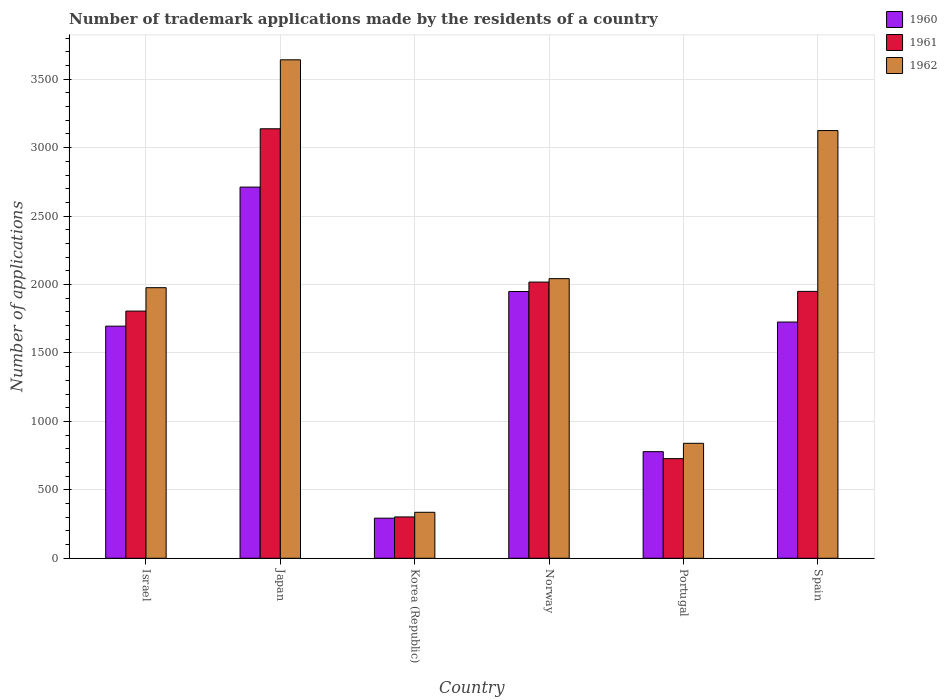How many different coloured bars are there?
Keep it short and to the point. 3. How many groups of bars are there?
Make the answer very short. 6. Are the number of bars on each tick of the X-axis equal?
Offer a terse response. Yes. How many bars are there on the 1st tick from the right?
Provide a short and direct response. 3. What is the number of trademark applications made by the residents in 1961 in Norway?
Your answer should be very brief. 2018. Across all countries, what is the maximum number of trademark applications made by the residents in 1962?
Your answer should be compact. 3642. Across all countries, what is the minimum number of trademark applications made by the residents in 1961?
Provide a succinct answer. 302. In which country was the number of trademark applications made by the residents in 1962 maximum?
Give a very brief answer. Japan. What is the total number of trademark applications made by the residents in 1962 in the graph?
Offer a terse response. 1.20e+04. What is the difference between the number of trademark applications made by the residents in 1961 in Japan and that in Portugal?
Offer a very short reply. 2410. What is the difference between the number of trademark applications made by the residents in 1961 in Portugal and the number of trademark applications made by the residents in 1960 in Spain?
Ensure brevity in your answer.  -998. What is the average number of trademark applications made by the residents in 1960 per country?
Offer a terse response. 1525.83. In how many countries, is the number of trademark applications made by the residents in 1961 greater than 2800?
Keep it short and to the point. 1. What is the ratio of the number of trademark applications made by the residents in 1960 in Norway to that in Portugal?
Give a very brief answer. 2.5. Is the number of trademark applications made by the residents in 1960 in Israel less than that in Norway?
Offer a very short reply. Yes. What is the difference between the highest and the second highest number of trademark applications made by the residents in 1961?
Keep it short and to the point. 1120. What is the difference between the highest and the lowest number of trademark applications made by the residents in 1962?
Offer a very short reply. 3306. In how many countries, is the number of trademark applications made by the residents in 1962 greater than the average number of trademark applications made by the residents in 1962 taken over all countries?
Keep it short and to the point. 3. Is the sum of the number of trademark applications made by the residents in 1960 in Israel and Korea (Republic) greater than the maximum number of trademark applications made by the residents in 1962 across all countries?
Ensure brevity in your answer.  No. What does the 2nd bar from the left in Norway represents?
Make the answer very short. 1961. How many bars are there?
Offer a terse response. 18. Are all the bars in the graph horizontal?
Give a very brief answer. No. How many countries are there in the graph?
Keep it short and to the point. 6. What is the difference between two consecutive major ticks on the Y-axis?
Offer a very short reply. 500. Does the graph contain any zero values?
Ensure brevity in your answer.  No. Does the graph contain grids?
Your answer should be compact. Yes. What is the title of the graph?
Provide a short and direct response. Number of trademark applications made by the residents of a country. Does "1960" appear as one of the legend labels in the graph?
Offer a very short reply. Yes. What is the label or title of the X-axis?
Ensure brevity in your answer.  Country. What is the label or title of the Y-axis?
Your response must be concise. Number of applications. What is the Number of applications of 1960 in Israel?
Give a very brief answer. 1696. What is the Number of applications in 1961 in Israel?
Make the answer very short. 1806. What is the Number of applications in 1962 in Israel?
Your answer should be very brief. 1977. What is the Number of applications of 1960 in Japan?
Provide a succinct answer. 2712. What is the Number of applications of 1961 in Japan?
Offer a very short reply. 3138. What is the Number of applications in 1962 in Japan?
Ensure brevity in your answer.  3642. What is the Number of applications in 1960 in Korea (Republic)?
Make the answer very short. 293. What is the Number of applications in 1961 in Korea (Republic)?
Give a very brief answer. 302. What is the Number of applications of 1962 in Korea (Republic)?
Provide a short and direct response. 336. What is the Number of applications in 1960 in Norway?
Your answer should be compact. 1949. What is the Number of applications of 1961 in Norway?
Your response must be concise. 2018. What is the Number of applications in 1962 in Norway?
Provide a short and direct response. 2043. What is the Number of applications in 1960 in Portugal?
Make the answer very short. 779. What is the Number of applications of 1961 in Portugal?
Give a very brief answer. 728. What is the Number of applications in 1962 in Portugal?
Give a very brief answer. 840. What is the Number of applications in 1960 in Spain?
Your response must be concise. 1726. What is the Number of applications of 1961 in Spain?
Keep it short and to the point. 1950. What is the Number of applications of 1962 in Spain?
Provide a succinct answer. 3125. Across all countries, what is the maximum Number of applications in 1960?
Your response must be concise. 2712. Across all countries, what is the maximum Number of applications in 1961?
Keep it short and to the point. 3138. Across all countries, what is the maximum Number of applications of 1962?
Your answer should be very brief. 3642. Across all countries, what is the minimum Number of applications in 1960?
Your answer should be very brief. 293. Across all countries, what is the minimum Number of applications of 1961?
Provide a short and direct response. 302. Across all countries, what is the minimum Number of applications of 1962?
Ensure brevity in your answer.  336. What is the total Number of applications in 1960 in the graph?
Provide a succinct answer. 9155. What is the total Number of applications in 1961 in the graph?
Provide a short and direct response. 9942. What is the total Number of applications in 1962 in the graph?
Offer a terse response. 1.20e+04. What is the difference between the Number of applications in 1960 in Israel and that in Japan?
Your answer should be compact. -1016. What is the difference between the Number of applications in 1961 in Israel and that in Japan?
Give a very brief answer. -1332. What is the difference between the Number of applications of 1962 in Israel and that in Japan?
Your answer should be very brief. -1665. What is the difference between the Number of applications of 1960 in Israel and that in Korea (Republic)?
Offer a terse response. 1403. What is the difference between the Number of applications of 1961 in Israel and that in Korea (Republic)?
Make the answer very short. 1504. What is the difference between the Number of applications in 1962 in Israel and that in Korea (Republic)?
Offer a very short reply. 1641. What is the difference between the Number of applications of 1960 in Israel and that in Norway?
Provide a short and direct response. -253. What is the difference between the Number of applications of 1961 in Israel and that in Norway?
Provide a succinct answer. -212. What is the difference between the Number of applications of 1962 in Israel and that in Norway?
Keep it short and to the point. -66. What is the difference between the Number of applications of 1960 in Israel and that in Portugal?
Give a very brief answer. 917. What is the difference between the Number of applications in 1961 in Israel and that in Portugal?
Offer a very short reply. 1078. What is the difference between the Number of applications of 1962 in Israel and that in Portugal?
Provide a short and direct response. 1137. What is the difference between the Number of applications in 1961 in Israel and that in Spain?
Make the answer very short. -144. What is the difference between the Number of applications of 1962 in Israel and that in Spain?
Give a very brief answer. -1148. What is the difference between the Number of applications of 1960 in Japan and that in Korea (Republic)?
Your response must be concise. 2419. What is the difference between the Number of applications in 1961 in Japan and that in Korea (Republic)?
Provide a short and direct response. 2836. What is the difference between the Number of applications in 1962 in Japan and that in Korea (Republic)?
Ensure brevity in your answer.  3306. What is the difference between the Number of applications of 1960 in Japan and that in Norway?
Keep it short and to the point. 763. What is the difference between the Number of applications in 1961 in Japan and that in Norway?
Keep it short and to the point. 1120. What is the difference between the Number of applications in 1962 in Japan and that in Norway?
Provide a short and direct response. 1599. What is the difference between the Number of applications in 1960 in Japan and that in Portugal?
Your response must be concise. 1933. What is the difference between the Number of applications of 1961 in Japan and that in Portugal?
Keep it short and to the point. 2410. What is the difference between the Number of applications of 1962 in Japan and that in Portugal?
Your response must be concise. 2802. What is the difference between the Number of applications in 1960 in Japan and that in Spain?
Offer a terse response. 986. What is the difference between the Number of applications in 1961 in Japan and that in Spain?
Your answer should be compact. 1188. What is the difference between the Number of applications in 1962 in Japan and that in Spain?
Offer a very short reply. 517. What is the difference between the Number of applications in 1960 in Korea (Republic) and that in Norway?
Your response must be concise. -1656. What is the difference between the Number of applications in 1961 in Korea (Republic) and that in Norway?
Offer a terse response. -1716. What is the difference between the Number of applications in 1962 in Korea (Republic) and that in Norway?
Give a very brief answer. -1707. What is the difference between the Number of applications of 1960 in Korea (Republic) and that in Portugal?
Offer a very short reply. -486. What is the difference between the Number of applications in 1961 in Korea (Republic) and that in Portugal?
Offer a very short reply. -426. What is the difference between the Number of applications in 1962 in Korea (Republic) and that in Portugal?
Ensure brevity in your answer.  -504. What is the difference between the Number of applications of 1960 in Korea (Republic) and that in Spain?
Your answer should be compact. -1433. What is the difference between the Number of applications in 1961 in Korea (Republic) and that in Spain?
Your response must be concise. -1648. What is the difference between the Number of applications of 1962 in Korea (Republic) and that in Spain?
Make the answer very short. -2789. What is the difference between the Number of applications in 1960 in Norway and that in Portugal?
Keep it short and to the point. 1170. What is the difference between the Number of applications in 1961 in Norway and that in Portugal?
Keep it short and to the point. 1290. What is the difference between the Number of applications of 1962 in Norway and that in Portugal?
Give a very brief answer. 1203. What is the difference between the Number of applications of 1960 in Norway and that in Spain?
Your response must be concise. 223. What is the difference between the Number of applications in 1962 in Norway and that in Spain?
Provide a short and direct response. -1082. What is the difference between the Number of applications in 1960 in Portugal and that in Spain?
Offer a very short reply. -947. What is the difference between the Number of applications of 1961 in Portugal and that in Spain?
Give a very brief answer. -1222. What is the difference between the Number of applications in 1962 in Portugal and that in Spain?
Your answer should be very brief. -2285. What is the difference between the Number of applications in 1960 in Israel and the Number of applications in 1961 in Japan?
Keep it short and to the point. -1442. What is the difference between the Number of applications of 1960 in Israel and the Number of applications of 1962 in Japan?
Your answer should be compact. -1946. What is the difference between the Number of applications in 1961 in Israel and the Number of applications in 1962 in Japan?
Your response must be concise. -1836. What is the difference between the Number of applications in 1960 in Israel and the Number of applications in 1961 in Korea (Republic)?
Ensure brevity in your answer.  1394. What is the difference between the Number of applications in 1960 in Israel and the Number of applications in 1962 in Korea (Republic)?
Make the answer very short. 1360. What is the difference between the Number of applications in 1961 in Israel and the Number of applications in 1962 in Korea (Republic)?
Keep it short and to the point. 1470. What is the difference between the Number of applications in 1960 in Israel and the Number of applications in 1961 in Norway?
Offer a terse response. -322. What is the difference between the Number of applications in 1960 in Israel and the Number of applications in 1962 in Norway?
Offer a terse response. -347. What is the difference between the Number of applications of 1961 in Israel and the Number of applications of 1962 in Norway?
Your response must be concise. -237. What is the difference between the Number of applications of 1960 in Israel and the Number of applications of 1961 in Portugal?
Offer a very short reply. 968. What is the difference between the Number of applications in 1960 in Israel and the Number of applications in 1962 in Portugal?
Your response must be concise. 856. What is the difference between the Number of applications of 1961 in Israel and the Number of applications of 1962 in Portugal?
Give a very brief answer. 966. What is the difference between the Number of applications of 1960 in Israel and the Number of applications of 1961 in Spain?
Offer a very short reply. -254. What is the difference between the Number of applications of 1960 in Israel and the Number of applications of 1962 in Spain?
Your answer should be compact. -1429. What is the difference between the Number of applications in 1961 in Israel and the Number of applications in 1962 in Spain?
Provide a succinct answer. -1319. What is the difference between the Number of applications in 1960 in Japan and the Number of applications in 1961 in Korea (Republic)?
Provide a succinct answer. 2410. What is the difference between the Number of applications in 1960 in Japan and the Number of applications in 1962 in Korea (Republic)?
Provide a short and direct response. 2376. What is the difference between the Number of applications in 1961 in Japan and the Number of applications in 1962 in Korea (Republic)?
Offer a very short reply. 2802. What is the difference between the Number of applications in 1960 in Japan and the Number of applications in 1961 in Norway?
Make the answer very short. 694. What is the difference between the Number of applications in 1960 in Japan and the Number of applications in 1962 in Norway?
Give a very brief answer. 669. What is the difference between the Number of applications of 1961 in Japan and the Number of applications of 1962 in Norway?
Your response must be concise. 1095. What is the difference between the Number of applications in 1960 in Japan and the Number of applications in 1961 in Portugal?
Provide a short and direct response. 1984. What is the difference between the Number of applications in 1960 in Japan and the Number of applications in 1962 in Portugal?
Offer a terse response. 1872. What is the difference between the Number of applications in 1961 in Japan and the Number of applications in 1962 in Portugal?
Your answer should be compact. 2298. What is the difference between the Number of applications of 1960 in Japan and the Number of applications of 1961 in Spain?
Ensure brevity in your answer.  762. What is the difference between the Number of applications of 1960 in Japan and the Number of applications of 1962 in Spain?
Your answer should be very brief. -413. What is the difference between the Number of applications in 1961 in Japan and the Number of applications in 1962 in Spain?
Provide a succinct answer. 13. What is the difference between the Number of applications in 1960 in Korea (Republic) and the Number of applications in 1961 in Norway?
Offer a terse response. -1725. What is the difference between the Number of applications in 1960 in Korea (Republic) and the Number of applications in 1962 in Norway?
Ensure brevity in your answer.  -1750. What is the difference between the Number of applications in 1961 in Korea (Republic) and the Number of applications in 1962 in Norway?
Your response must be concise. -1741. What is the difference between the Number of applications in 1960 in Korea (Republic) and the Number of applications in 1961 in Portugal?
Your answer should be compact. -435. What is the difference between the Number of applications in 1960 in Korea (Republic) and the Number of applications in 1962 in Portugal?
Keep it short and to the point. -547. What is the difference between the Number of applications in 1961 in Korea (Republic) and the Number of applications in 1962 in Portugal?
Your answer should be very brief. -538. What is the difference between the Number of applications in 1960 in Korea (Republic) and the Number of applications in 1961 in Spain?
Offer a terse response. -1657. What is the difference between the Number of applications in 1960 in Korea (Republic) and the Number of applications in 1962 in Spain?
Offer a terse response. -2832. What is the difference between the Number of applications of 1961 in Korea (Republic) and the Number of applications of 1962 in Spain?
Make the answer very short. -2823. What is the difference between the Number of applications in 1960 in Norway and the Number of applications in 1961 in Portugal?
Ensure brevity in your answer.  1221. What is the difference between the Number of applications of 1960 in Norway and the Number of applications of 1962 in Portugal?
Provide a short and direct response. 1109. What is the difference between the Number of applications in 1961 in Norway and the Number of applications in 1962 in Portugal?
Ensure brevity in your answer.  1178. What is the difference between the Number of applications in 1960 in Norway and the Number of applications in 1962 in Spain?
Your response must be concise. -1176. What is the difference between the Number of applications in 1961 in Norway and the Number of applications in 1962 in Spain?
Keep it short and to the point. -1107. What is the difference between the Number of applications of 1960 in Portugal and the Number of applications of 1961 in Spain?
Give a very brief answer. -1171. What is the difference between the Number of applications in 1960 in Portugal and the Number of applications in 1962 in Spain?
Provide a short and direct response. -2346. What is the difference between the Number of applications in 1961 in Portugal and the Number of applications in 1962 in Spain?
Provide a succinct answer. -2397. What is the average Number of applications in 1960 per country?
Ensure brevity in your answer.  1525.83. What is the average Number of applications in 1961 per country?
Your answer should be very brief. 1657. What is the average Number of applications in 1962 per country?
Offer a terse response. 1993.83. What is the difference between the Number of applications of 1960 and Number of applications of 1961 in Israel?
Offer a terse response. -110. What is the difference between the Number of applications of 1960 and Number of applications of 1962 in Israel?
Ensure brevity in your answer.  -281. What is the difference between the Number of applications in 1961 and Number of applications in 1962 in Israel?
Ensure brevity in your answer.  -171. What is the difference between the Number of applications of 1960 and Number of applications of 1961 in Japan?
Give a very brief answer. -426. What is the difference between the Number of applications in 1960 and Number of applications in 1962 in Japan?
Provide a succinct answer. -930. What is the difference between the Number of applications in 1961 and Number of applications in 1962 in Japan?
Provide a succinct answer. -504. What is the difference between the Number of applications in 1960 and Number of applications in 1961 in Korea (Republic)?
Your answer should be very brief. -9. What is the difference between the Number of applications in 1960 and Number of applications in 1962 in Korea (Republic)?
Offer a very short reply. -43. What is the difference between the Number of applications of 1961 and Number of applications of 1962 in Korea (Republic)?
Provide a short and direct response. -34. What is the difference between the Number of applications of 1960 and Number of applications of 1961 in Norway?
Your response must be concise. -69. What is the difference between the Number of applications in 1960 and Number of applications in 1962 in Norway?
Provide a succinct answer. -94. What is the difference between the Number of applications of 1960 and Number of applications of 1961 in Portugal?
Provide a short and direct response. 51. What is the difference between the Number of applications in 1960 and Number of applications in 1962 in Portugal?
Your answer should be very brief. -61. What is the difference between the Number of applications of 1961 and Number of applications of 1962 in Portugal?
Keep it short and to the point. -112. What is the difference between the Number of applications in 1960 and Number of applications in 1961 in Spain?
Provide a succinct answer. -224. What is the difference between the Number of applications in 1960 and Number of applications in 1962 in Spain?
Offer a terse response. -1399. What is the difference between the Number of applications in 1961 and Number of applications in 1962 in Spain?
Offer a terse response. -1175. What is the ratio of the Number of applications of 1960 in Israel to that in Japan?
Provide a succinct answer. 0.63. What is the ratio of the Number of applications of 1961 in Israel to that in Japan?
Your answer should be compact. 0.58. What is the ratio of the Number of applications of 1962 in Israel to that in Japan?
Make the answer very short. 0.54. What is the ratio of the Number of applications of 1960 in Israel to that in Korea (Republic)?
Provide a short and direct response. 5.79. What is the ratio of the Number of applications in 1961 in Israel to that in Korea (Republic)?
Your answer should be very brief. 5.98. What is the ratio of the Number of applications in 1962 in Israel to that in Korea (Republic)?
Provide a short and direct response. 5.88. What is the ratio of the Number of applications of 1960 in Israel to that in Norway?
Make the answer very short. 0.87. What is the ratio of the Number of applications of 1961 in Israel to that in Norway?
Offer a terse response. 0.89. What is the ratio of the Number of applications of 1962 in Israel to that in Norway?
Make the answer very short. 0.97. What is the ratio of the Number of applications in 1960 in Israel to that in Portugal?
Make the answer very short. 2.18. What is the ratio of the Number of applications in 1961 in Israel to that in Portugal?
Make the answer very short. 2.48. What is the ratio of the Number of applications in 1962 in Israel to that in Portugal?
Offer a terse response. 2.35. What is the ratio of the Number of applications of 1960 in Israel to that in Spain?
Your response must be concise. 0.98. What is the ratio of the Number of applications of 1961 in Israel to that in Spain?
Provide a short and direct response. 0.93. What is the ratio of the Number of applications in 1962 in Israel to that in Spain?
Provide a short and direct response. 0.63. What is the ratio of the Number of applications of 1960 in Japan to that in Korea (Republic)?
Provide a succinct answer. 9.26. What is the ratio of the Number of applications in 1961 in Japan to that in Korea (Republic)?
Give a very brief answer. 10.39. What is the ratio of the Number of applications in 1962 in Japan to that in Korea (Republic)?
Your answer should be compact. 10.84. What is the ratio of the Number of applications of 1960 in Japan to that in Norway?
Provide a short and direct response. 1.39. What is the ratio of the Number of applications of 1961 in Japan to that in Norway?
Give a very brief answer. 1.55. What is the ratio of the Number of applications in 1962 in Japan to that in Norway?
Offer a terse response. 1.78. What is the ratio of the Number of applications of 1960 in Japan to that in Portugal?
Make the answer very short. 3.48. What is the ratio of the Number of applications in 1961 in Japan to that in Portugal?
Offer a terse response. 4.31. What is the ratio of the Number of applications of 1962 in Japan to that in Portugal?
Provide a short and direct response. 4.34. What is the ratio of the Number of applications in 1960 in Japan to that in Spain?
Provide a short and direct response. 1.57. What is the ratio of the Number of applications in 1961 in Japan to that in Spain?
Make the answer very short. 1.61. What is the ratio of the Number of applications in 1962 in Japan to that in Spain?
Ensure brevity in your answer.  1.17. What is the ratio of the Number of applications in 1960 in Korea (Republic) to that in Norway?
Offer a terse response. 0.15. What is the ratio of the Number of applications of 1961 in Korea (Republic) to that in Norway?
Provide a succinct answer. 0.15. What is the ratio of the Number of applications of 1962 in Korea (Republic) to that in Norway?
Your answer should be compact. 0.16. What is the ratio of the Number of applications in 1960 in Korea (Republic) to that in Portugal?
Keep it short and to the point. 0.38. What is the ratio of the Number of applications of 1961 in Korea (Republic) to that in Portugal?
Your answer should be very brief. 0.41. What is the ratio of the Number of applications in 1962 in Korea (Republic) to that in Portugal?
Provide a short and direct response. 0.4. What is the ratio of the Number of applications of 1960 in Korea (Republic) to that in Spain?
Your response must be concise. 0.17. What is the ratio of the Number of applications of 1961 in Korea (Republic) to that in Spain?
Keep it short and to the point. 0.15. What is the ratio of the Number of applications of 1962 in Korea (Republic) to that in Spain?
Your answer should be very brief. 0.11. What is the ratio of the Number of applications of 1960 in Norway to that in Portugal?
Your response must be concise. 2.5. What is the ratio of the Number of applications of 1961 in Norway to that in Portugal?
Offer a very short reply. 2.77. What is the ratio of the Number of applications of 1962 in Norway to that in Portugal?
Offer a terse response. 2.43. What is the ratio of the Number of applications of 1960 in Norway to that in Spain?
Offer a very short reply. 1.13. What is the ratio of the Number of applications in 1961 in Norway to that in Spain?
Your answer should be compact. 1.03. What is the ratio of the Number of applications in 1962 in Norway to that in Spain?
Offer a terse response. 0.65. What is the ratio of the Number of applications of 1960 in Portugal to that in Spain?
Give a very brief answer. 0.45. What is the ratio of the Number of applications of 1961 in Portugal to that in Spain?
Your answer should be compact. 0.37. What is the ratio of the Number of applications of 1962 in Portugal to that in Spain?
Offer a terse response. 0.27. What is the difference between the highest and the second highest Number of applications in 1960?
Ensure brevity in your answer.  763. What is the difference between the highest and the second highest Number of applications in 1961?
Ensure brevity in your answer.  1120. What is the difference between the highest and the second highest Number of applications in 1962?
Ensure brevity in your answer.  517. What is the difference between the highest and the lowest Number of applications of 1960?
Keep it short and to the point. 2419. What is the difference between the highest and the lowest Number of applications in 1961?
Your answer should be very brief. 2836. What is the difference between the highest and the lowest Number of applications in 1962?
Your answer should be very brief. 3306. 